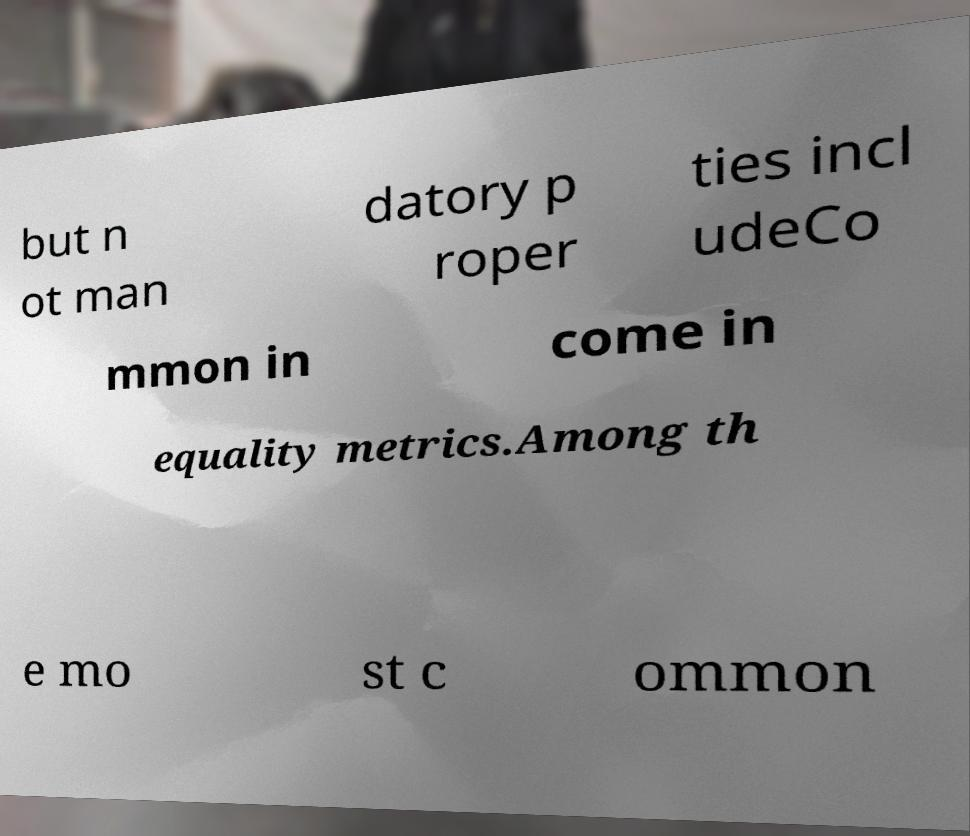I need the written content from this picture converted into text. Can you do that? but n ot man datory p roper ties incl udeCo mmon in come in equality metrics.Among th e mo st c ommon 